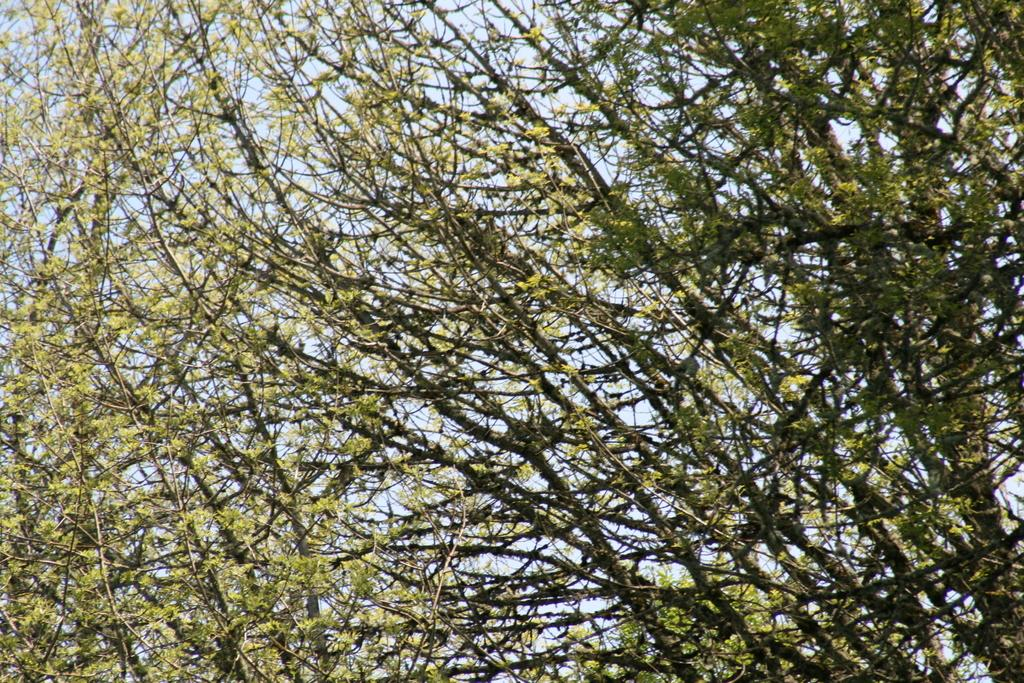What type of vegetation can be seen in the image? There are trees in the image. What part of the natural environment is visible in the image? The sky is visible in the image. What type of money is being produced by the trees in the image? There is no money being produced by the trees in the image; they are simply trees. What type of beam is holding up the sky in the image? There is no beam holding up the sky in the image; the sky is visible as a natural part of the environment. 